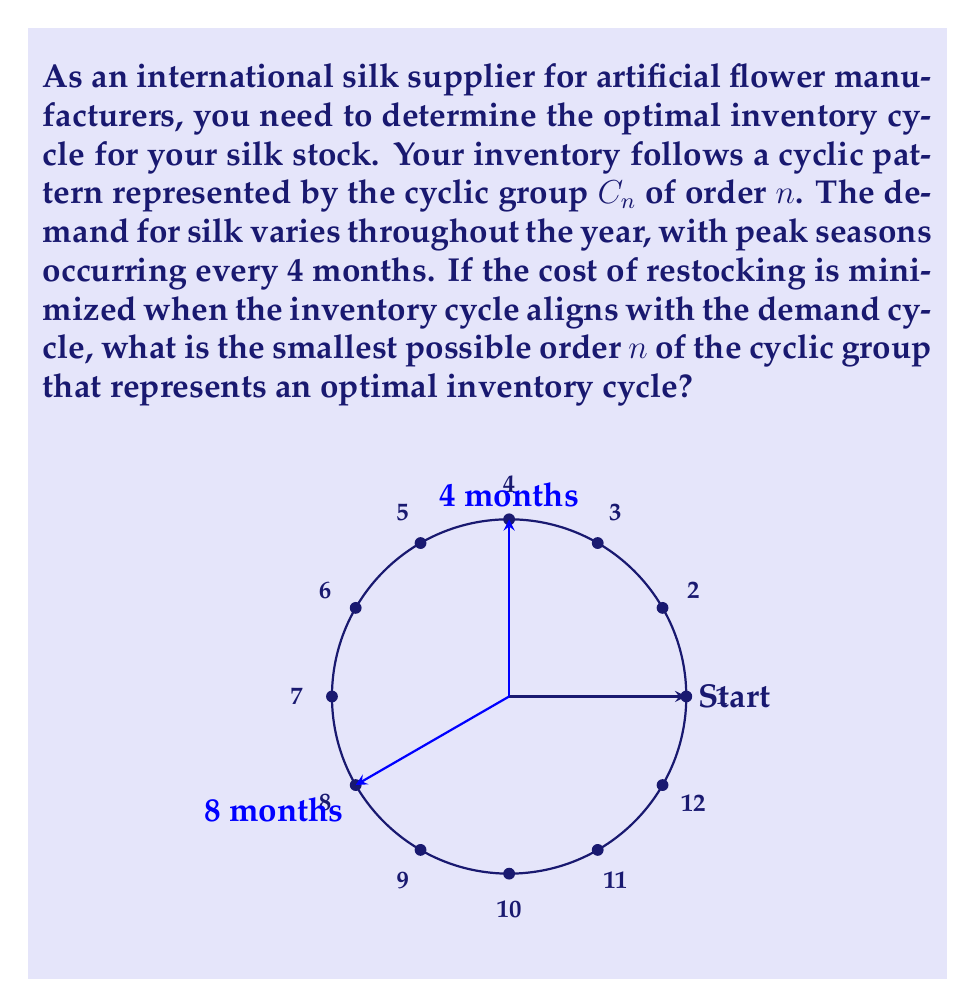Provide a solution to this math problem. To solve this problem, we need to consider the following steps:

1) The demand cycle peaks every 4 months, which means it completes 3 full cycles in a year (12 months / 4 months = 3 cycles).

2) For the inventory cycle to align perfectly with the demand cycle, it must complete a whole number of cycles in a year.

3) In cyclic group theory, this means we're looking for the smallest $n$ such that:
   $$n \mid 12$$
   where $\mid$ denotes "divides".

4) The divisors of 12 are: 1, 2, 3, 4, 6, and 12.

5) However, we need the inventory cycle to align with the demand cycle, which occurs every 4 months. This means our cycle length must be a multiple of 4.

6) The multiples of 4 that divide 12 are 4 and 12.

7) The smallest of these is 4.

Therefore, the cyclic group $C_4$ of order 4 represents the optimal inventory cycle.

This means the inventory should go through 4 cycles per year, which perfectly aligns with the 3 peak demand periods (as 4 is the least common multiple of 3 and 4).
Answer: 4 